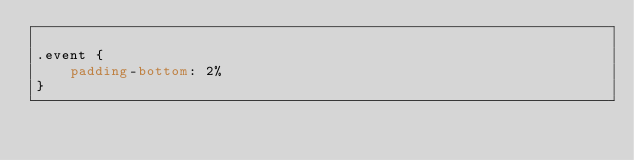Convert code to text. <code><loc_0><loc_0><loc_500><loc_500><_CSS_>
.event {
    padding-bottom: 2%
}</code> 